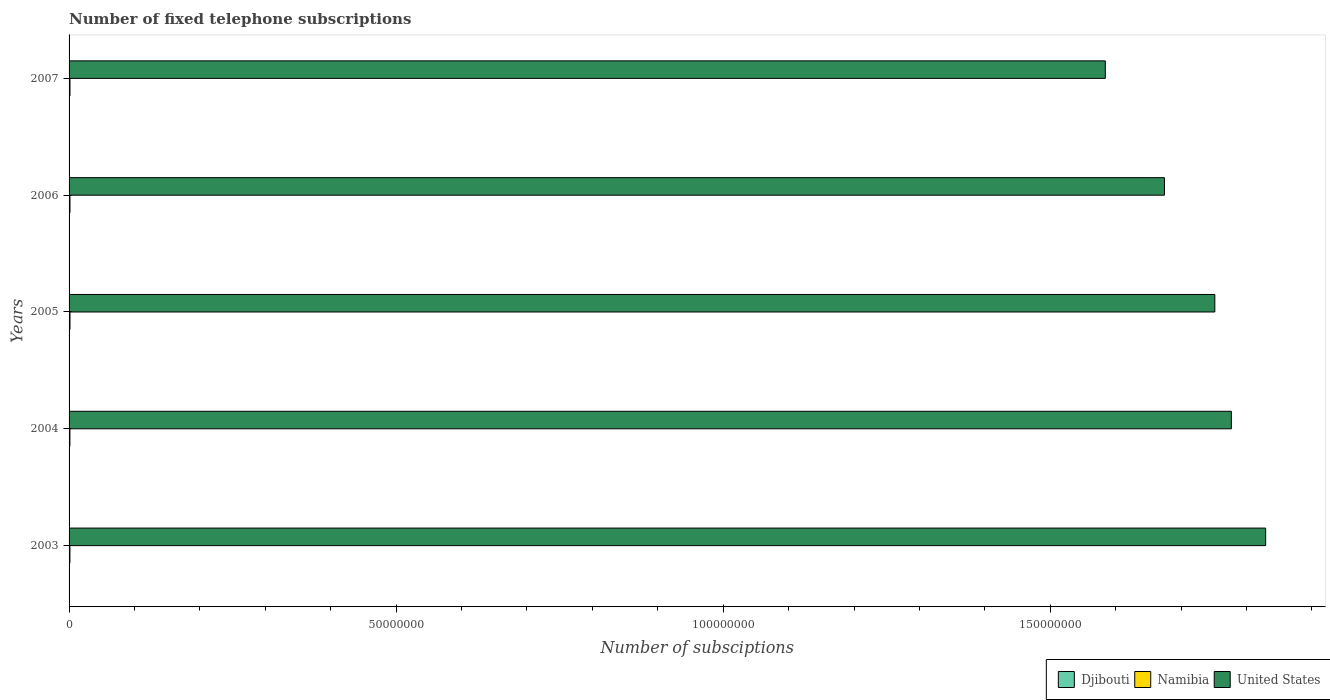How many different coloured bars are there?
Provide a short and direct response. 3. How many groups of bars are there?
Your answer should be compact. 5. How many bars are there on the 1st tick from the bottom?
Provide a succinct answer. 3. What is the number of fixed telephone subscriptions in Djibouti in 2004?
Provide a succinct answer. 1.11e+04. Across all years, what is the maximum number of fixed telephone subscriptions in Djibouti?
Your response must be concise. 1.41e+04. Across all years, what is the minimum number of fixed telephone subscriptions in United States?
Your answer should be very brief. 1.58e+08. In which year was the number of fixed telephone subscriptions in United States maximum?
Ensure brevity in your answer.  2003. In which year was the number of fixed telephone subscriptions in Namibia minimum?
Ensure brevity in your answer.  2003. What is the total number of fixed telephone subscriptions in Namibia in the graph?
Your response must be concise. 6.69e+05. What is the difference between the number of fixed telephone subscriptions in Djibouti in 2005 and that in 2006?
Give a very brief answer. -723. What is the difference between the number of fixed telephone subscriptions in Namibia in 2006 and the number of fixed telephone subscriptions in United States in 2007?
Provide a succinct answer. -1.58e+08. What is the average number of fixed telephone subscriptions in Namibia per year?
Keep it short and to the point. 1.34e+05. In the year 2006, what is the difference between the number of fixed telephone subscriptions in Namibia and number of fixed telephone subscriptions in United States?
Provide a succinct answer. -1.67e+08. In how many years, is the number of fixed telephone subscriptions in Namibia greater than 100000000 ?
Provide a succinct answer. 0. What is the ratio of the number of fixed telephone subscriptions in Djibouti in 2003 to that in 2005?
Ensure brevity in your answer.  0.96. Is the number of fixed telephone subscriptions in Namibia in 2003 less than that in 2004?
Provide a succinct answer. Yes. Is the difference between the number of fixed telephone subscriptions in Namibia in 2006 and 2007 greater than the difference between the number of fixed telephone subscriptions in United States in 2006 and 2007?
Make the answer very short. No. What is the difference between the highest and the second highest number of fixed telephone subscriptions in Djibouti?
Give a very brief answer. 2812. What is the difference between the highest and the lowest number of fixed telephone subscriptions in United States?
Your answer should be very brief. 2.45e+07. In how many years, is the number of fixed telephone subscriptions in United States greater than the average number of fixed telephone subscriptions in United States taken over all years?
Offer a terse response. 3. Is the sum of the number of fixed telephone subscriptions in Namibia in 2004 and 2007 greater than the maximum number of fixed telephone subscriptions in Djibouti across all years?
Your answer should be very brief. Yes. What does the 1st bar from the top in 2007 represents?
Offer a terse response. United States. What does the 1st bar from the bottom in 2003 represents?
Give a very brief answer. Djibouti. Are all the bars in the graph horizontal?
Your answer should be very brief. Yes. How many years are there in the graph?
Make the answer very short. 5. Are the values on the major ticks of X-axis written in scientific E-notation?
Offer a very short reply. No. Does the graph contain any zero values?
Your answer should be compact. No. Does the graph contain grids?
Make the answer very short. No. How many legend labels are there?
Provide a short and direct response. 3. How are the legend labels stacked?
Offer a terse response. Horizontal. What is the title of the graph?
Provide a short and direct response. Number of fixed telephone subscriptions. Does "Lesotho" appear as one of the legend labels in the graph?
Your answer should be compact. No. What is the label or title of the X-axis?
Make the answer very short. Number of subsciptions. What is the Number of subsciptions in Djibouti in 2003?
Keep it short and to the point. 1.02e+04. What is the Number of subsciptions of Namibia in 2003?
Ensure brevity in your answer.  1.27e+05. What is the Number of subsciptions in United States in 2003?
Your response must be concise. 1.83e+08. What is the Number of subsciptions in Djibouti in 2004?
Ensure brevity in your answer.  1.11e+04. What is the Number of subsciptions of Namibia in 2004?
Give a very brief answer. 1.28e+05. What is the Number of subsciptions in United States in 2004?
Your answer should be very brief. 1.78e+08. What is the Number of subsciptions of Djibouti in 2005?
Provide a short and direct response. 1.06e+04. What is the Number of subsciptions of Namibia in 2005?
Keep it short and to the point. 1.39e+05. What is the Number of subsciptions of United States in 2005?
Your response must be concise. 1.75e+08. What is the Number of subsciptions of Djibouti in 2006?
Your answer should be compact. 1.13e+04. What is the Number of subsciptions in Namibia in 2006?
Make the answer very short. 1.36e+05. What is the Number of subsciptions of United States in 2006?
Provide a short and direct response. 1.67e+08. What is the Number of subsciptions in Djibouti in 2007?
Ensure brevity in your answer.  1.41e+04. What is the Number of subsciptions of Namibia in 2007?
Ensure brevity in your answer.  1.38e+05. What is the Number of subsciptions in United States in 2007?
Make the answer very short. 1.58e+08. Across all years, what is the maximum Number of subsciptions in Djibouti?
Your answer should be very brief. 1.41e+04. Across all years, what is the maximum Number of subsciptions of Namibia?
Offer a terse response. 1.39e+05. Across all years, what is the maximum Number of subsciptions of United States?
Your answer should be compact. 1.83e+08. Across all years, what is the minimum Number of subsciptions in Djibouti?
Provide a short and direct response. 1.02e+04. Across all years, what is the minimum Number of subsciptions in Namibia?
Provide a succinct answer. 1.27e+05. Across all years, what is the minimum Number of subsciptions in United States?
Give a very brief answer. 1.58e+08. What is the total Number of subsciptions of Djibouti in the graph?
Offer a terse response. 5.73e+04. What is the total Number of subsciptions of Namibia in the graph?
Provide a succinct answer. 6.69e+05. What is the total Number of subsciptions in United States in the graph?
Your answer should be compact. 8.62e+08. What is the difference between the Number of subsciptions of Djibouti in 2003 and that in 2004?
Your answer should be compact. -934. What is the difference between the Number of subsciptions in Namibia in 2003 and that in 2004?
Make the answer very short. -555. What is the difference between the Number of subsciptions in United States in 2003 and that in 2004?
Your answer should be very brief. 5.24e+06. What is the difference between the Number of subsciptions in Djibouti in 2003 and that in 2005?
Your response must be concise. -409. What is the difference between the Number of subsciptions of Namibia in 2003 and that in 2005?
Make the answer very short. -1.16e+04. What is the difference between the Number of subsciptions of United States in 2003 and that in 2005?
Provide a succinct answer. 7.77e+06. What is the difference between the Number of subsciptions in Djibouti in 2003 and that in 2006?
Provide a succinct answer. -1132. What is the difference between the Number of subsciptions of Namibia in 2003 and that in 2006?
Keep it short and to the point. -8783. What is the difference between the Number of subsciptions of United States in 2003 and that in 2006?
Offer a terse response. 1.55e+07. What is the difference between the Number of subsciptions of Djibouti in 2003 and that in 2007?
Your answer should be compact. -3944. What is the difference between the Number of subsciptions in Namibia in 2003 and that in 2007?
Make the answer very short. -1.08e+04. What is the difference between the Number of subsciptions of United States in 2003 and that in 2007?
Your answer should be compact. 2.45e+07. What is the difference between the Number of subsciptions of Djibouti in 2004 and that in 2005?
Your response must be concise. 525. What is the difference between the Number of subsciptions in Namibia in 2004 and that in 2005?
Provide a succinct answer. -1.11e+04. What is the difference between the Number of subsciptions in United States in 2004 and that in 2005?
Your answer should be compact. 2.53e+06. What is the difference between the Number of subsciptions of Djibouti in 2004 and that in 2006?
Provide a succinct answer. -198. What is the difference between the Number of subsciptions of Namibia in 2004 and that in 2006?
Your answer should be compact. -8228. What is the difference between the Number of subsciptions in United States in 2004 and that in 2006?
Offer a very short reply. 1.02e+07. What is the difference between the Number of subsciptions in Djibouti in 2004 and that in 2007?
Your response must be concise. -3010. What is the difference between the Number of subsciptions of Namibia in 2004 and that in 2007?
Offer a very short reply. -1.02e+04. What is the difference between the Number of subsciptions of United States in 2004 and that in 2007?
Offer a very short reply. 1.93e+07. What is the difference between the Number of subsciptions in Djibouti in 2005 and that in 2006?
Make the answer very short. -723. What is the difference between the Number of subsciptions in Namibia in 2005 and that in 2006?
Give a very brief answer. 2834. What is the difference between the Number of subsciptions in United States in 2005 and that in 2006?
Provide a succinct answer. 7.70e+06. What is the difference between the Number of subsciptions in Djibouti in 2005 and that in 2007?
Make the answer very short. -3535. What is the difference between the Number of subsciptions in Namibia in 2005 and that in 2007?
Provide a succinct answer. 826. What is the difference between the Number of subsciptions of United States in 2005 and that in 2007?
Your response must be concise. 1.67e+07. What is the difference between the Number of subsciptions of Djibouti in 2006 and that in 2007?
Make the answer very short. -2812. What is the difference between the Number of subsciptions of Namibia in 2006 and that in 2007?
Your response must be concise. -2008. What is the difference between the Number of subsciptions in United States in 2006 and that in 2007?
Your answer should be compact. 9.04e+06. What is the difference between the Number of subsciptions of Djibouti in 2003 and the Number of subsciptions of Namibia in 2004?
Ensure brevity in your answer.  -1.18e+05. What is the difference between the Number of subsciptions of Djibouti in 2003 and the Number of subsciptions of United States in 2004?
Offer a terse response. -1.78e+08. What is the difference between the Number of subsciptions in Namibia in 2003 and the Number of subsciptions in United States in 2004?
Keep it short and to the point. -1.78e+08. What is the difference between the Number of subsciptions of Djibouti in 2003 and the Number of subsciptions of Namibia in 2005?
Your answer should be very brief. -1.29e+05. What is the difference between the Number of subsciptions of Djibouti in 2003 and the Number of subsciptions of United States in 2005?
Make the answer very short. -1.75e+08. What is the difference between the Number of subsciptions in Namibia in 2003 and the Number of subsciptions in United States in 2005?
Provide a succinct answer. -1.75e+08. What is the difference between the Number of subsciptions in Djibouti in 2003 and the Number of subsciptions in Namibia in 2006?
Give a very brief answer. -1.26e+05. What is the difference between the Number of subsciptions in Djibouti in 2003 and the Number of subsciptions in United States in 2006?
Give a very brief answer. -1.67e+08. What is the difference between the Number of subsciptions of Namibia in 2003 and the Number of subsciptions of United States in 2006?
Offer a very short reply. -1.67e+08. What is the difference between the Number of subsciptions in Djibouti in 2003 and the Number of subsciptions in Namibia in 2007?
Give a very brief answer. -1.28e+05. What is the difference between the Number of subsciptions in Djibouti in 2003 and the Number of subsciptions in United States in 2007?
Your answer should be compact. -1.58e+08. What is the difference between the Number of subsciptions of Namibia in 2003 and the Number of subsciptions of United States in 2007?
Provide a short and direct response. -1.58e+08. What is the difference between the Number of subsciptions of Djibouti in 2004 and the Number of subsciptions of Namibia in 2005?
Keep it short and to the point. -1.28e+05. What is the difference between the Number of subsciptions of Djibouti in 2004 and the Number of subsciptions of United States in 2005?
Your response must be concise. -1.75e+08. What is the difference between the Number of subsciptions in Namibia in 2004 and the Number of subsciptions in United States in 2005?
Provide a succinct answer. -1.75e+08. What is the difference between the Number of subsciptions of Djibouti in 2004 and the Number of subsciptions of Namibia in 2006?
Offer a very short reply. -1.25e+05. What is the difference between the Number of subsciptions of Djibouti in 2004 and the Number of subsciptions of United States in 2006?
Provide a short and direct response. -1.67e+08. What is the difference between the Number of subsciptions in Namibia in 2004 and the Number of subsciptions in United States in 2006?
Make the answer very short. -1.67e+08. What is the difference between the Number of subsciptions in Djibouti in 2004 and the Number of subsciptions in Namibia in 2007?
Give a very brief answer. -1.27e+05. What is the difference between the Number of subsciptions in Djibouti in 2004 and the Number of subsciptions in United States in 2007?
Give a very brief answer. -1.58e+08. What is the difference between the Number of subsciptions of Namibia in 2004 and the Number of subsciptions of United States in 2007?
Your answer should be compact. -1.58e+08. What is the difference between the Number of subsciptions of Djibouti in 2005 and the Number of subsciptions of Namibia in 2006?
Ensure brevity in your answer.  -1.26e+05. What is the difference between the Number of subsciptions of Djibouti in 2005 and the Number of subsciptions of United States in 2006?
Offer a very short reply. -1.67e+08. What is the difference between the Number of subsciptions in Namibia in 2005 and the Number of subsciptions in United States in 2006?
Keep it short and to the point. -1.67e+08. What is the difference between the Number of subsciptions in Djibouti in 2005 and the Number of subsciptions in Namibia in 2007?
Provide a short and direct response. -1.28e+05. What is the difference between the Number of subsciptions in Djibouti in 2005 and the Number of subsciptions in United States in 2007?
Your response must be concise. -1.58e+08. What is the difference between the Number of subsciptions of Namibia in 2005 and the Number of subsciptions of United States in 2007?
Your answer should be very brief. -1.58e+08. What is the difference between the Number of subsciptions of Djibouti in 2006 and the Number of subsciptions of Namibia in 2007?
Your answer should be very brief. -1.27e+05. What is the difference between the Number of subsciptions of Djibouti in 2006 and the Number of subsciptions of United States in 2007?
Provide a succinct answer. -1.58e+08. What is the difference between the Number of subsciptions in Namibia in 2006 and the Number of subsciptions in United States in 2007?
Your answer should be very brief. -1.58e+08. What is the average Number of subsciptions in Djibouti per year?
Make the answer very short. 1.15e+04. What is the average Number of subsciptions in Namibia per year?
Ensure brevity in your answer.  1.34e+05. What is the average Number of subsciptions in United States per year?
Ensure brevity in your answer.  1.72e+08. In the year 2003, what is the difference between the Number of subsciptions in Djibouti and Number of subsciptions in Namibia?
Give a very brief answer. -1.17e+05. In the year 2003, what is the difference between the Number of subsciptions in Djibouti and Number of subsciptions in United States?
Give a very brief answer. -1.83e+08. In the year 2003, what is the difference between the Number of subsciptions in Namibia and Number of subsciptions in United States?
Offer a very short reply. -1.83e+08. In the year 2004, what is the difference between the Number of subsciptions in Djibouti and Number of subsciptions in Namibia?
Make the answer very short. -1.17e+05. In the year 2004, what is the difference between the Number of subsciptions in Djibouti and Number of subsciptions in United States?
Your answer should be compact. -1.78e+08. In the year 2004, what is the difference between the Number of subsciptions in Namibia and Number of subsciptions in United States?
Ensure brevity in your answer.  -1.78e+08. In the year 2005, what is the difference between the Number of subsciptions in Djibouti and Number of subsciptions in Namibia?
Ensure brevity in your answer.  -1.28e+05. In the year 2005, what is the difference between the Number of subsciptions in Djibouti and Number of subsciptions in United States?
Make the answer very short. -1.75e+08. In the year 2005, what is the difference between the Number of subsciptions in Namibia and Number of subsciptions in United States?
Keep it short and to the point. -1.75e+08. In the year 2006, what is the difference between the Number of subsciptions in Djibouti and Number of subsciptions in Namibia?
Give a very brief answer. -1.25e+05. In the year 2006, what is the difference between the Number of subsciptions of Djibouti and Number of subsciptions of United States?
Offer a very short reply. -1.67e+08. In the year 2006, what is the difference between the Number of subsciptions in Namibia and Number of subsciptions in United States?
Your answer should be compact. -1.67e+08. In the year 2007, what is the difference between the Number of subsciptions in Djibouti and Number of subsciptions in Namibia?
Your answer should be compact. -1.24e+05. In the year 2007, what is the difference between the Number of subsciptions of Djibouti and Number of subsciptions of United States?
Provide a short and direct response. -1.58e+08. In the year 2007, what is the difference between the Number of subsciptions of Namibia and Number of subsciptions of United States?
Your response must be concise. -1.58e+08. What is the ratio of the Number of subsciptions of Djibouti in 2003 to that in 2004?
Your response must be concise. 0.92. What is the ratio of the Number of subsciptions in Namibia in 2003 to that in 2004?
Provide a succinct answer. 1. What is the ratio of the Number of subsciptions in United States in 2003 to that in 2004?
Your answer should be compact. 1.03. What is the ratio of the Number of subsciptions of Djibouti in 2003 to that in 2005?
Give a very brief answer. 0.96. What is the ratio of the Number of subsciptions of Namibia in 2003 to that in 2005?
Keep it short and to the point. 0.92. What is the ratio of the Number of subsciptions of United States in 2003 to that in 2005?
Make the answer very short. 1.04. What is the ratio of the Number of subsciptions in Djibouti in 2003 to that in 2006?
Provide a short and direct response. 0.9. What is the ratio of the Number of subsciptions of Namibia in 2003 to that in 2006?
Your response must be concise. 0.94. What is the ratio of the Number of subsciptions in United States in 2003 to that in 2006?
Provide a short and direct response. 1.09. What is the ratio of the Number of subsciptions of Djibouti in 2003 to that in 2007?
Your answer should be compact. 0.72. What is the ratio of the Number of subsciptions in Namibia in 2003 to that in 2007?
Your response must be concise. 0.92. What is the ratio of the Number of subsciptions in United States in 2003 to that in 2007?
Provide a short and direct response. 1.15. What is the ratio of the Number of subsciptions of Djibouti in 2004 to that in 2005?
Your response must be concise. 1.05. What is the ratio of the Number of subsciptions in Namibia in 2004 to that in 2005?
Offer a very short reply. 0.92. What is the ratio of the Number of subsciptions in United States in 2004 to that in 2005?
Provide a short and direct response. 1.01. What is the ratio of the Number of subsciptions of Djibouti in 2004 to that in 2006?
Give a very brief answer. 0.98. What is the ratio of the Number of subsciptions of Namibia in 2004 to that in 2006?
Make the answer very short. 0.94. What is the ratio of the Number of subsciptions in United States in 2004 to that in 2006?
Make the answer very short. 1.06. What is the ratio of the Number of subsciptions of Djibouti in 2004 to that in 2007?
Your response must be concise. 0.79. What is the ratio of the Number of subsciptions in Namibia in 2004 to that in 2007?
Your response must be concise. 0.93. What is the ratio of the Number of subsciptions in United States in 2004 to that in 2007?
Make the answer very short. 1.12. What is the ratio of the Number of subsciptions in Djibouti in 2005 to that in 2006?
Your answer should be compact. 0.94. What is the ratio of the Number of subsciptions in Namibia in 2005 to that in 2006?
Your answer should be very brief. 1.02. What is the ratio of the Number of subsciptions in United States in 2005 to that in 2006?
Provide a short and direct response. 1.05. What is the ratio of the Number of subsciptions of Djibouti in 2005 to that in 2007?
Your answer should be compact. 0.75. What is the ratio of the Number of subsciptions of United States in 2005 to that in 2007?
Keep it short and to the point. 1.11. What is the ratio of the Number of subsciptions of Djibouti in 2006 to that in 2007?
Make the answer very short. 0.8. What is the ratio of the Number of subsciptions in Namibia in 2006 to that in 2007?
Offer a terse response. 0.99. What is the ratio of the Number of subsciptions of United States in 2006 to that in 2007?
Offer a terse response. 1.06. What is the difference between the highest and the second highest Number of subsciptions of Djibouti?
Your answer should be very brief. 2812. What is the difference between the highest and the second highest Number of subsciptions of Namibia?
Provide a short and direct response. 826. What is the difference between the highest and the second highest Number of subsciptions of United States?
Your answer should be very brief. 5.24e+06. What is the difference between the highest and the lowest Number of subsciptions of Djibouti?
Give a very brief answer. 3944. What is the difference between the highest and the lowest Number of subsciptions of Namibia?
Give a very brief answer. 1.16e+04. What is the difference between the highest and the lowest Number of subsciptions in United States?
Your response must be concise. 2.45e+07. 